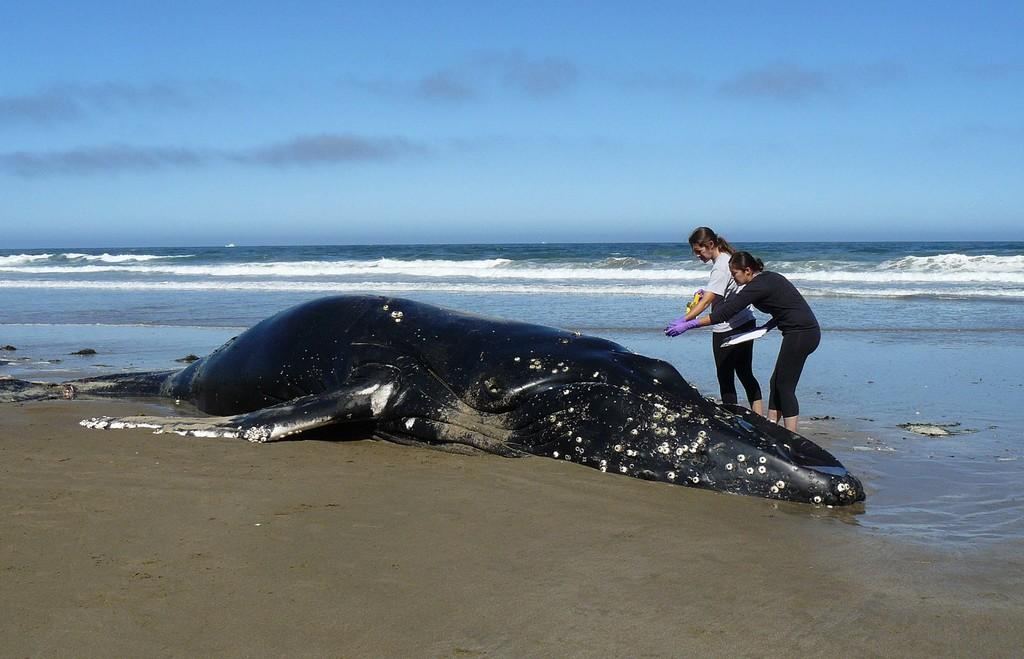What is the main subject in the center of the image? There is a whale in the center of the image. Can you describe the people in the image? There are two ladies in the image. What type of environment is depicted in the image? There is water and sand at the bottom of the image. What type of polish is being applied to the tree in the image? There is no tree present in the image, and therefore no polish being applied. What channel is the whale swimming in the image? The question refers to a channel, which is not present in the image. 